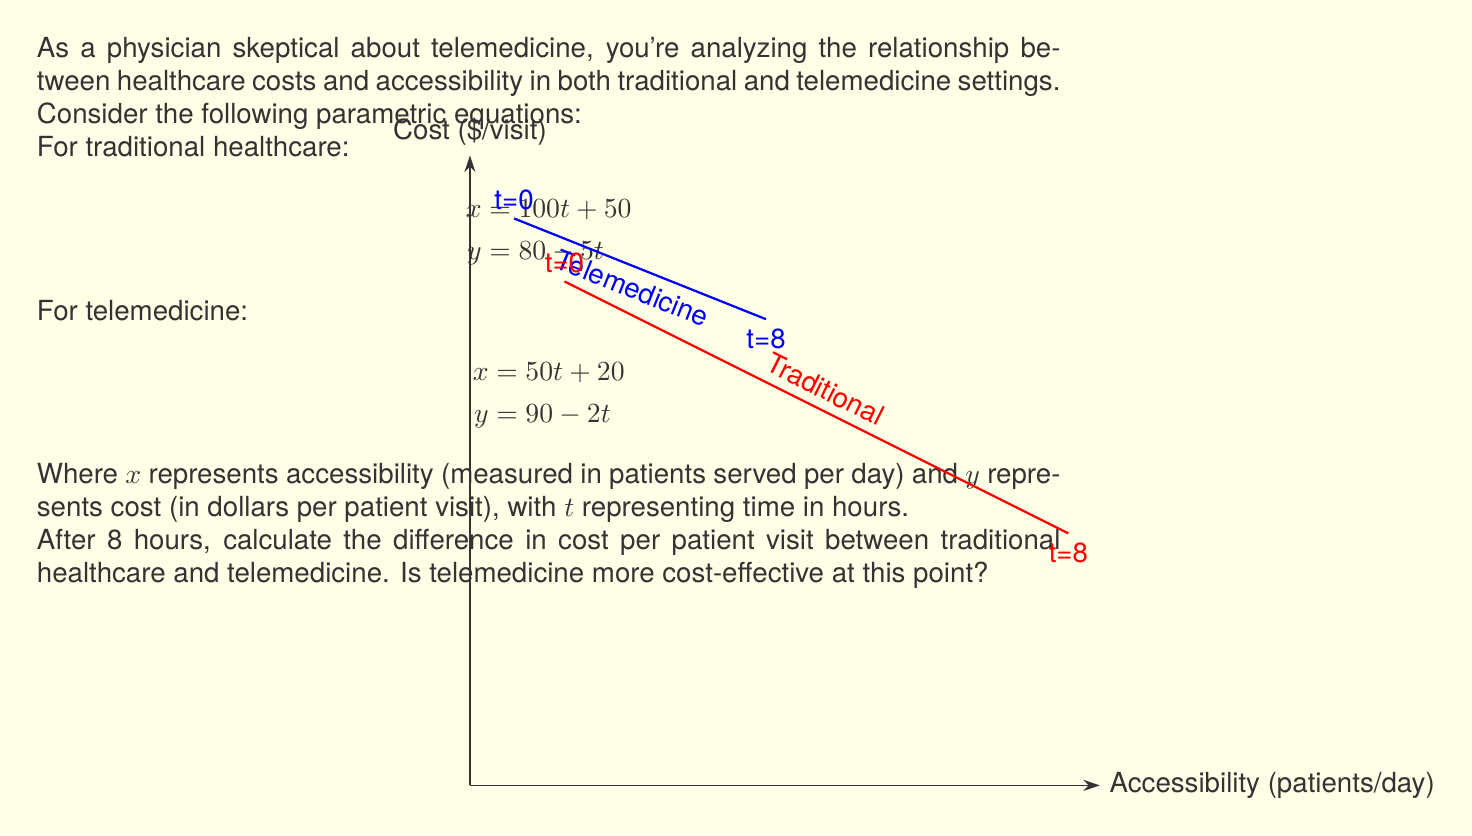What is the answer to this math problem? Let's approach this step-by-step:

1) First, we need to calculate the values of $x$ and $y$ for both traditional healthcare and telemedicine at $t=8$ hours.

2) For traditional healthcare:
   $$x = 100t + 50 = 100(8) + 50 = 850$$
   $$y = 80 - 5t = 80 - 5(8) = 40$$

3) For telemedicine:
   $$x = 50t + 20 = 50(8) + 20 = 420$$
   $$y = 90 - 2t = 90 - 2(8) = 74$$

4) Now, we can see that after 8 hours:
   - Traditional healthcare serves 850 patients at $40 per visit
   - Telemedicine serves 420 patients at $74 per visit

5) The difference in cost per patient visit is:
   $$74 - 40 = 34$$

6) Telemedicine is $34 more expensive per patient visit at this point.

7) To determine if telemedicine is more cost-effective, we need to consider both cost and accessibility. While telemedicine is more expensive per visit, it may still be more accessible to certain populations. However, purely from a cost perspective, traditional healthcare is more cost-effective at this point.
Answer: $34 more expensive per visit for telemedicine; traditional healthcare is more cost-effective. 